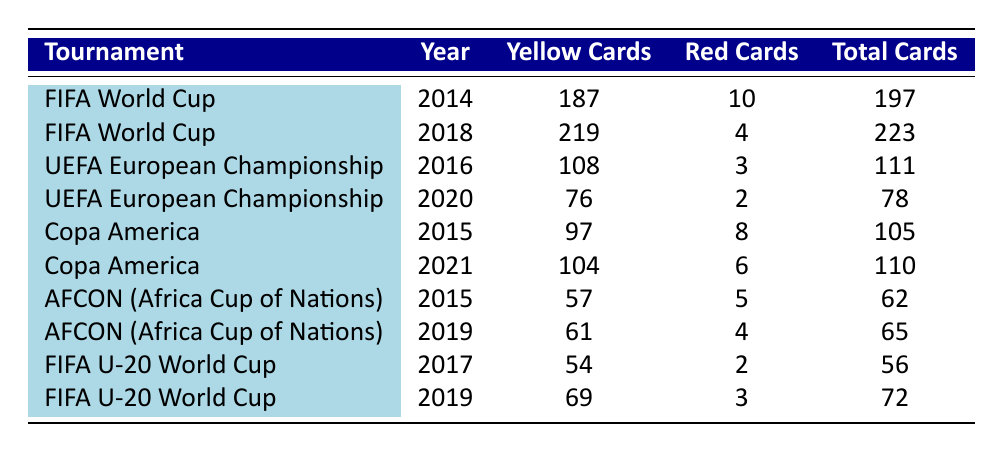What was the total number of yellow cards issued in the FIFA World Cup for both years? For the FIFA World Cup, we have yellow cards issued in 2014 as 187 and in 2018 as 219. Adding these values gives us 187 + 219 = 406, so the total number of yellow cards issued is 406.
Answer: 406 Which tournament had the highest number of yellow cards? By examining the yellow card counts in the table, we find that the FIFA World Cup in 2018 had the highest yellow cards with a total of 219.
Answer: FIFA World Cup 2018 Did AFCON (Africa Cup of Nations) issue more red cards in 2015 compared to 2019? The table shows that AFCON in 2015 issued 5 red cards, while in 2019 it issued 4 red cards. Comparing the two values, 5 is greater than 4.
Answer: Yes What is the average number of red cards issued across all tournaments? To find the average, we first sum up all the red cards: 10 + 4 + 3 + 2 + 8 + 6 + 5 + 4 + 2 + 3 = 47. There are a total of 10 tournaments, so we divide by 10: 47 / 10 = 4.7. Therefore, the average number of red cards is 4.7.
Answer: 4.7 Is it true that all Copa America tournaments had more yellow cards than red cards issued? For both Copa America tournaments, in 2015 there were 97 yellow cards and 8 red cards (yes), and in 2021, there were 104 yellow cards and 6 red cards (yes). Thus, both instances confirm that yellow cards outnumbered red cards.
Answer: Yes In which tournament was the total number of cards the lowest? The total number of cards for each tournament can be calculated: FIFA World Cup 2014 (197), FIFA World Cup 2018 (223), UEFA Euro 2016 (111), UEFA Euro 2020 (78), Copa America 2015 (105), Copa America 2021 (110), AFCON 2015 (62), AFCON 2019 (65), FIFA U-20 World Cup 2017 (56), and FIFA U-20 World Cup 2019 (72). The lowest total is seen in FIFA U-20 World Cup 2017 with 56 cards.
Answer: FIFA U-20 World Cup 2017 How many more yellow cards were issued in the FIFA World Cup 2018 compared to the UEFA European Championship 2020? The FIFA World Cup 2018 had 219 yellow cards and UEFA Euro 2020 had 76 yellow cards. The difference is calculated as 219 - 76 = 143, indicating that there were 143 more yellow cards issued in the FIFA World Cup 2018.
Answer: 143 What was the total number of cards issued in the UEFA European Championship 2016? For the UEFA European Championship 2016, we gather the values: 108 yellow cards and 3 red cards, yielding a total of 108 + 3 = 111 cards issued.
Answer: 111 